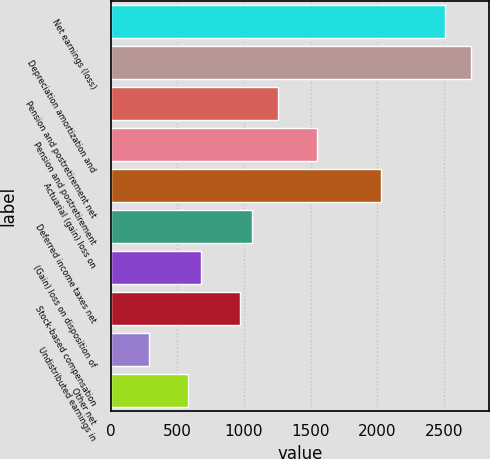Convert chart to OTSL. <chart><loc_0><loc_0><loc_500><loc_500><bar_chart><fcel>Net earnings (loss)<fcel>Depreciation amortization and<fcel>Pension and postretirement net<fcel>Pension and postretirement<fcel>Actuarial (gain) loss on<fcel>Deferred income taxes net<fcel>(Gain) loss on disposition of<fcel>Stock-based compensation<fcel>Undistributed earnings in<fcel>Other net<nl><fcel>2511<fcel>2704<fcel>1256.5<fcel>1546<fcel>2028.5<fcel>1063.5<fcel>677.5<fcel>967<fcel>291.5<fcel>581<nl></chart> 